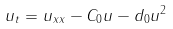Convert formula to latex. <formula><loc_0><loc_0><loc_500><loc_500>u _ { t } = u _ { x x } - C _ { 0 } u - d _ { 0 } u ^ { 2 }</formula> 